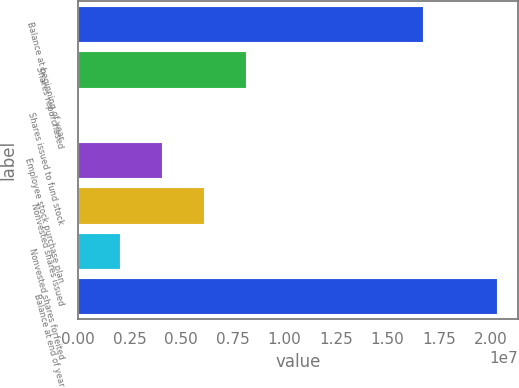Convert chart to OTSL. <chart><loc_0><loc_0><loc_500><loc_500><bar_chart><fcel>Balance at beginning of year<fcel>Shares repurchased<fcel>Shares issued to fund stock<fcel>Employee stock purchase plan<fcel>Nonvested shares issued<fcel>Nonvested shares forfeited<fcel>Balance at end of year<nl><fcel>1.67456e+07<fcel>8.13162e+06<fcel>9110<fcel>4.07036e+06<fcel>6.10099e+06<fcel>2.03974e+06<fcel>2.03154e+07<nl></chart> 